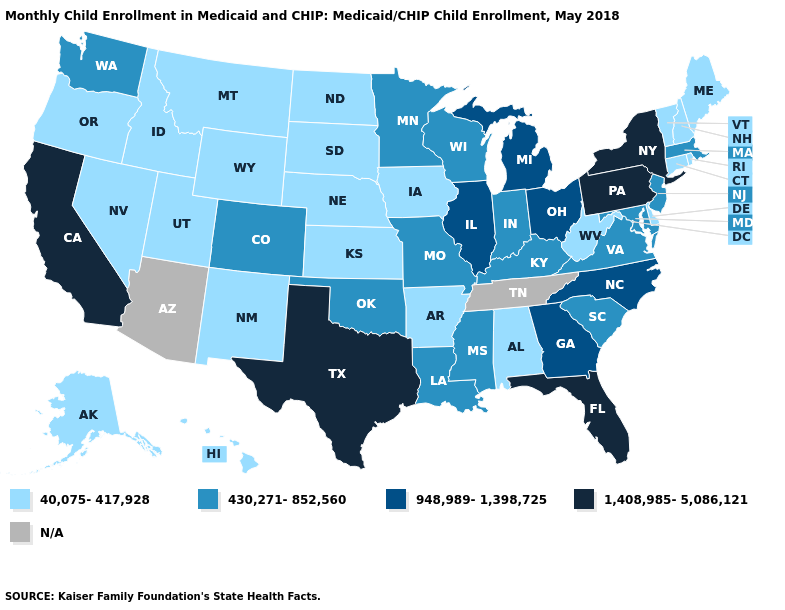Name the states that have a value in the range N/A?
Keep it brief. Arizona, Tennessee. What is the value of Mississippi?
Answer briefly. 430,271-852,560. Name the states that have a value in the range 430,271-852,560?
Keep it brief. Colorado, Indiana, Kentucky, Louisiana, Maryland, Massachusetts, Minnesota, Mississippi, Missouri, New Jersey, Oklahoma, South Carolina, Virginia, Washington, Wisconsin. Which states have the lowest value in the South?
Answer briefly. Alabama, Arkansas, Delaware, West Virginia. What is the lowest value in states that border South Dakota?
Keep it brief. 40,075-417,928. Name the states that have a value in the range 40,075-417,928?
Short answer required. Alabama, Alaska, Arkansas, Connecticut, Delaware, Hawaii, Idaho, Iowa, Kansas, Maine, Montana, Nebraska, Nevada, New Hampshire, New Mexico, North Dakota, Oregon, Rhode Island, South Dakota, Utah, Vermont, West Virginia, Wyoming. Name the states that have a value in the range 40,075-417,928?
Be succinct. Alabama, Alaska, Arkansas, Connecticut, Delaware, Hawaii, Idaho, Iowa, Kansas, Maine, Montana, Nebraska, Nevada, New Hampshire, New Mexico, North Dakota, Oregon, Rhode Island, South Dakota, Utah, Vermont, West Virginia, Wyoming. Does Michigan have the highest value in the MidWest?
Answer briefly. Yes. What is the highest value in the MidWest ?
Concise answer only. 948,989-1,398,725. Does the first symbol in the legend represent the smallest category?
Quick response, please. Yes. Name the states that have a value in the range 1,408,985-5,086,121?
Concise answer only. California, Florida, New York, Pennsylvania, Texas. Name the states that have a value in the range N/A?
Quick response, please. Arizona, Tennessee. What is the lowest value in the West?
Quick response, please. 40,075-417,928. 